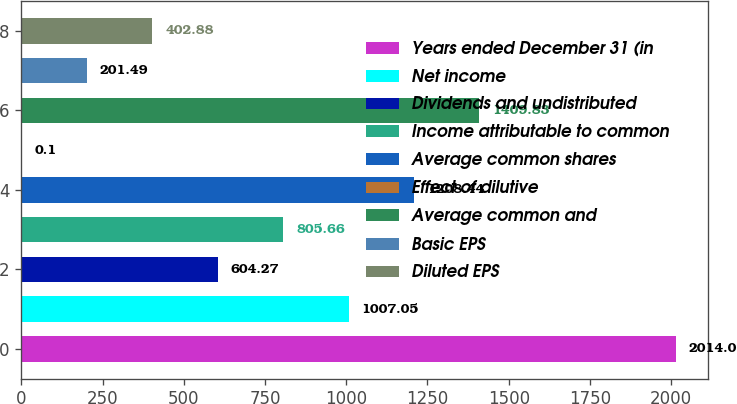<chart> <loc_0><loc_0><loc_500><loc_500><bar_chart><fcel>Years ended December 31 (in<fcel>Net income<fcel>Dividends and undistributed<fcel>Income attributable to common<fcel>Average common shares<fcel>Effect of dilutive<fcel>Average common and<fcel>Basic EPS<fcel>Diluted EPS<nl><fcel>2014<fcel>1007.05<fcel>604.27<fcel>805.66<fcel>1208.44<fcel>0.1<fcel>1409.83<fcel>201.49<fcel>402.88<nl></chart> 